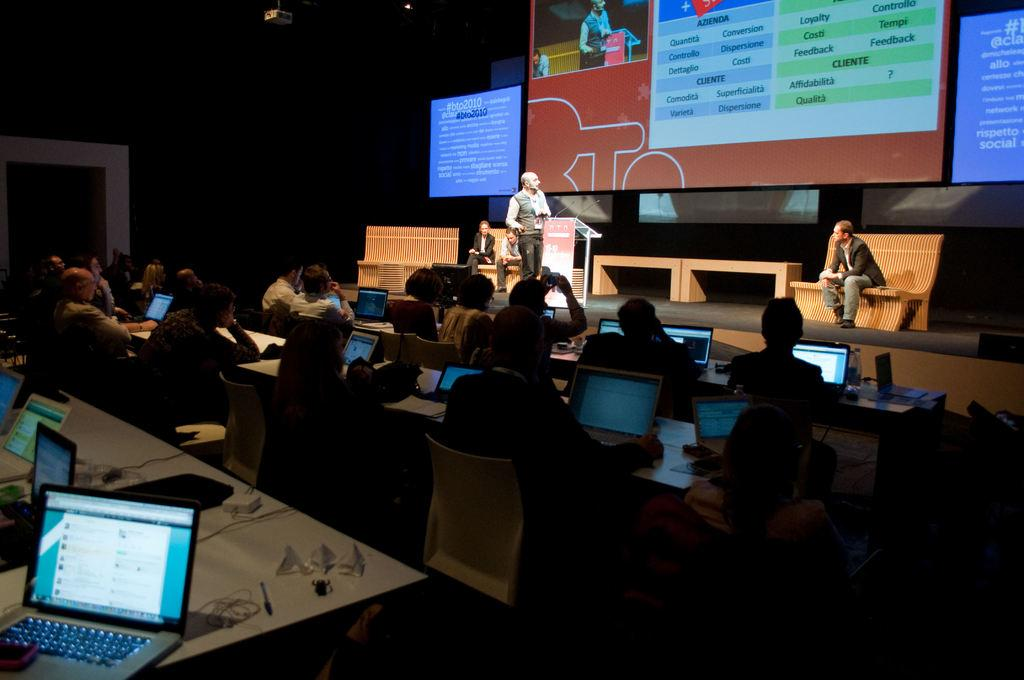<image>
Create a compact narrative representing the image presented. Students in a large room with computers listening to a presenter speaking about clients and business. 